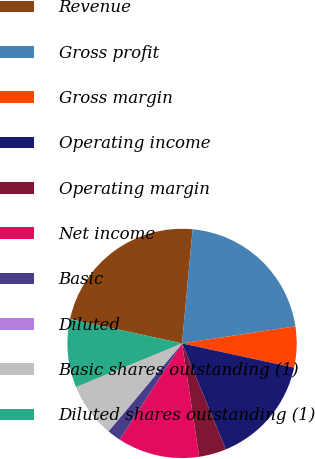<chart> <loc_0><loc_0><loc_500><loc_500><pie_chart><fcel>Revenue<fcel>Gross profit<fcel>Gross margin<fcel>Operating income<fcel>Operating margin<fcel>Net income<fcel>Basic<fcel>Diluted<fcel>Basic shares outstanding (1)<fcel>Diluted shares outstanding (1)<nl><fcel>23.07%<fcel>21.15%<fcel>5.77%<fcel>15.38%<fcel>3.85%<fcel>11.54%<fcel>1.93%<fcel>0.01%<fcel>7.69%<fcel>9.62%<nl></chart> 